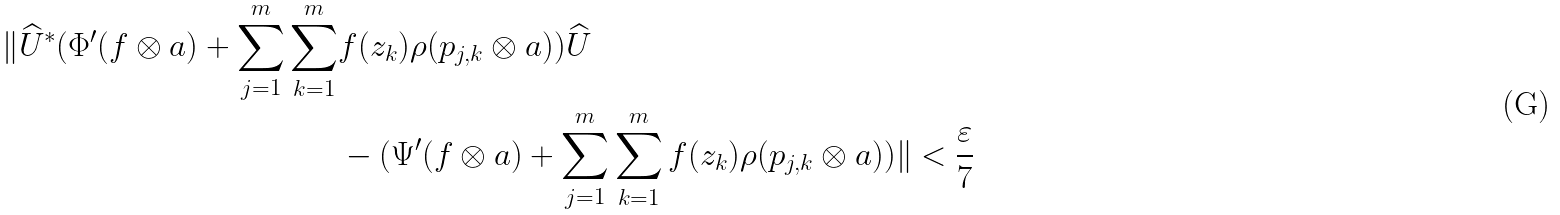Convert formula to latex. <formula><loc_0><loc_0><loc_500><loc_500>\| \widehat { U } ^ { * } ( \Phi ^ { \prime } ( f \otimes a ) + \sum _ { j = 1 } ^ { m } \sum _ { k = 1 } ^ { m } & f ( z _ { k } ) \rho ( p _ { j , k } \otimes a ) ) \widehat { U } \\ & - ( \Psi ^ { \prime } ( f \otimes a ) + \sum _ { j = 1 } ^ { m } \sum _ { k = 1 } ^ { m } f ( z _ { k } ) \rho ( p _ { j , k } \otimes a ) ) \| < \frac { \varepsilon } { 7 }</formula> 